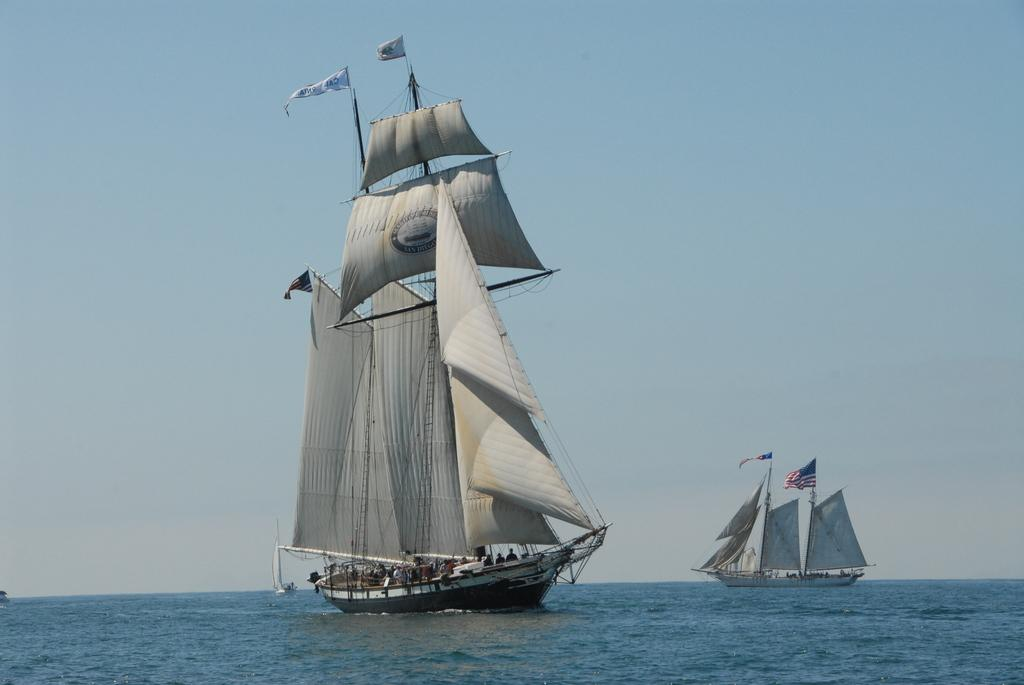What is in the water in the image? There are ships in the water. Who or what is inside the ships? There are people in the ships. What else can be found inside the ships? There are other objects in the ships. What is visible at the top of the ships? There are flags at the top of the ships. What type of bait is being used by the people in the ships? There is no mention of bait or fishing in the image, so it cannot be determined what type of bait might be used. Is the water in the image a lake? The image does not specify the type of water body, so it cannot be determined if it is a lake or not. 